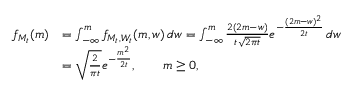<formula> <loc_0><loc_0><loc_500><loc_500>{ \begin{array} { r l } { f _ { M _ { t } } ( m ) } & { = \int _ { - \infty } ^ { m } f _ { M _ { t } , W _ { t } } ( m , w ) \, d w = \int _ { - \infty } ^ { m } { \frac { 2 ( 2 m - w ) } { t { \sqrt { 2 \pi t } } } } e ^ { - { \frac { ( 2 m - w ) ^ { 2 } } { 2 t } } } \, d w } \\ & { = { \sqrt { \frac { 2 } { \pi t } } } e ^ { - { \frac { m ^ { 2 } } { 2 t } } } , \quad m \geq 0 , } \end{array} }</formula> 